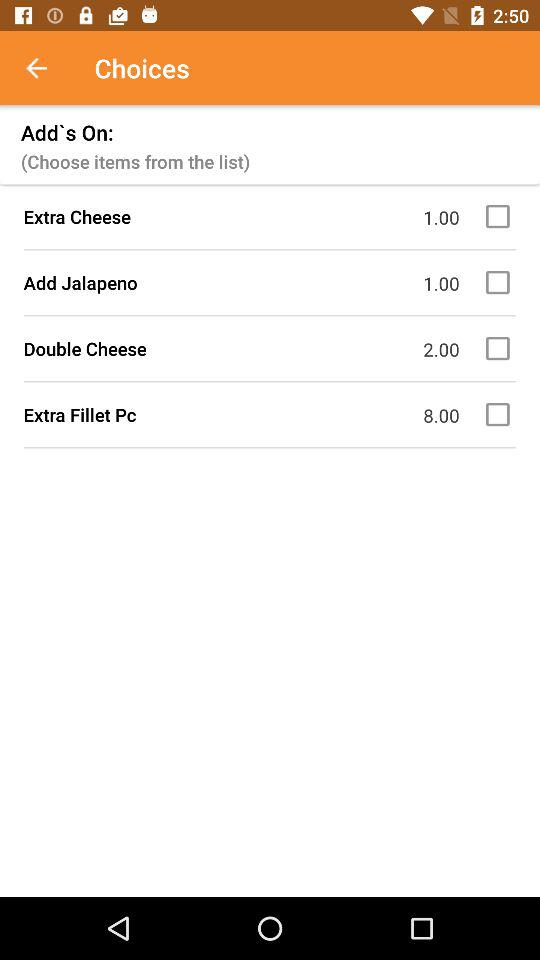What is the price of the "Extra Fillet Pc"? The price is 8. 